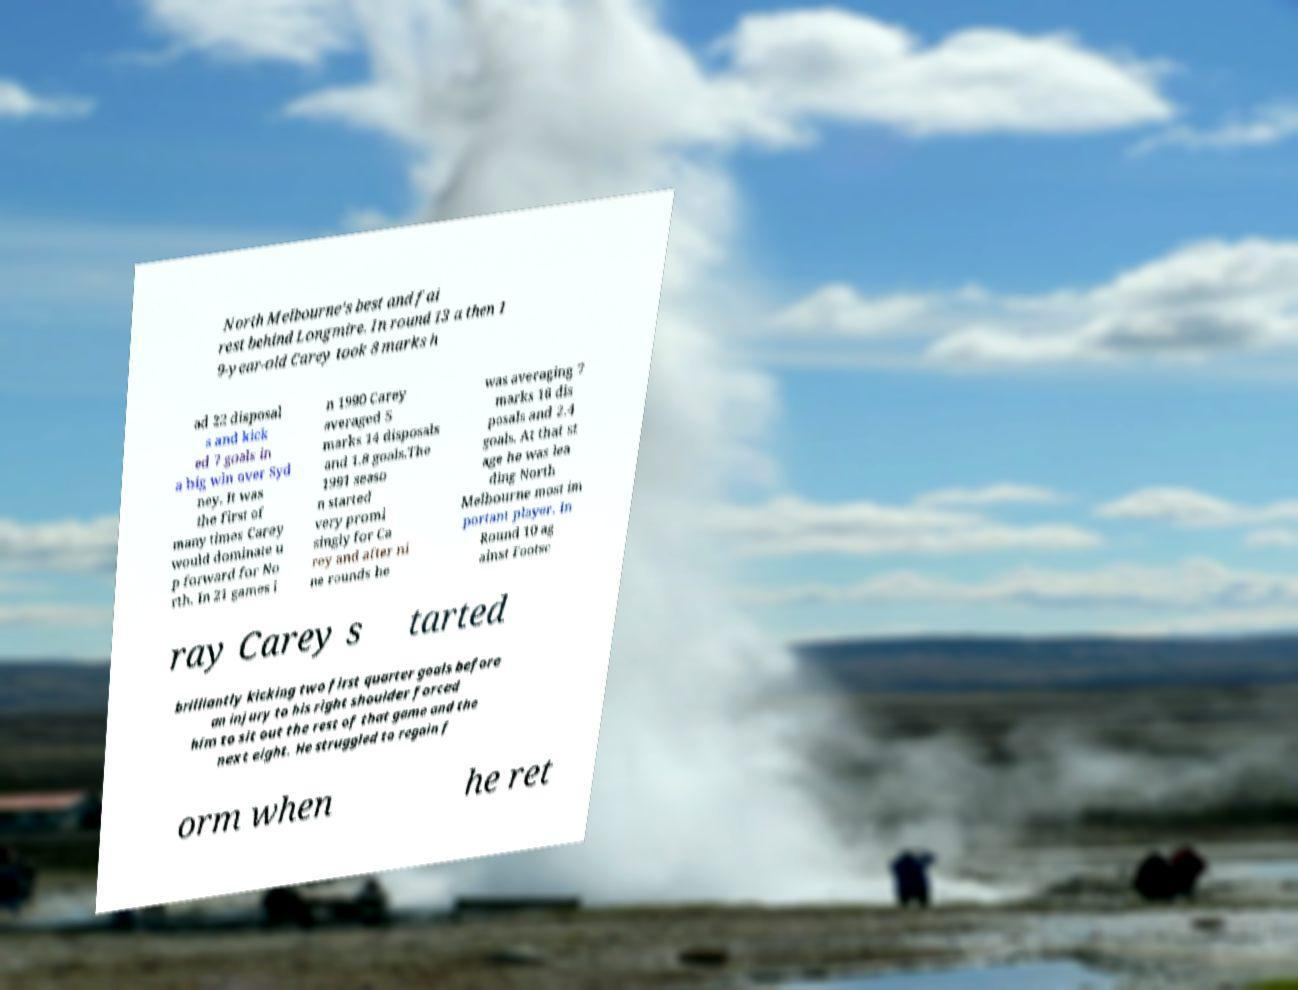Could you assist in decoding the text presented in this image and type it out clearly? North Melbourne's best and fai rest behind Longmire. In round 13 a then 1 9-year-old Carey took 8 marks h ad 22 disposal s and kick ed 7 goals in a big win over Syd ney. It was the first of many times Carey would dominate u p forward for No rth. In 21 games i n 1990 Carey averaged 5 marks 14 disposals and 1.8 goals.The 1991 seaso n started very promi singly for Ca rey and after ni ne rounds he was averaging 7 marks 16 dis posals and 2.4 goals. At that st age he was lea ding North Melbourne most im portant player. In Round 10 ag ainst Footsc ray Carey s tarted brilliantly kicking two first quarter goals before an injury to his right shoulder forced him to sit out the rest of that game and the next eight. He struggled to regain f orm when he ret 